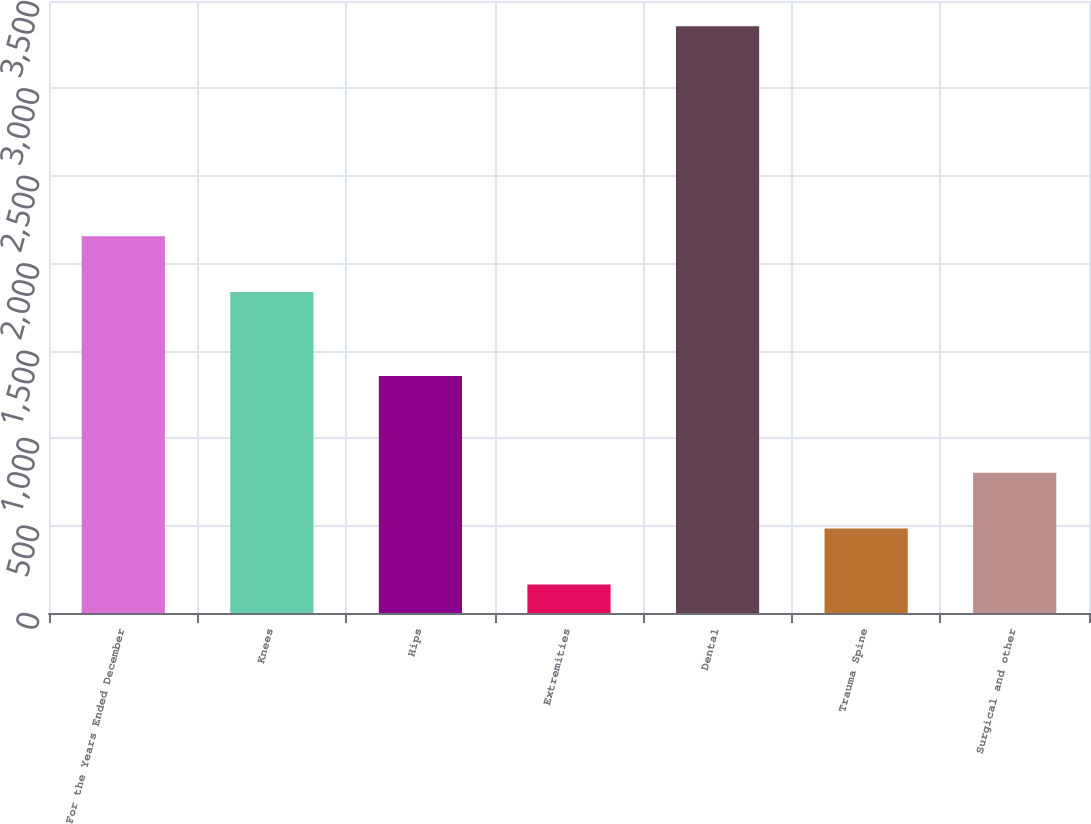Convert chart. <chart><loc_0><loc_0><loc_500><loc_500><bar_chart><fcel>For the Years Ended December<fcel>Knees<fcel>Hips<fcel>Extremities<fcel>Dental<fcel>Trauma Spine<fcel>Surgical and other<nl><fcel>2155.05<fcel>1835.9<fcel>1355.6<fcel>163.4<fcel>3354.9<fcel>482.55<fcel>801.7<nl></chart> 